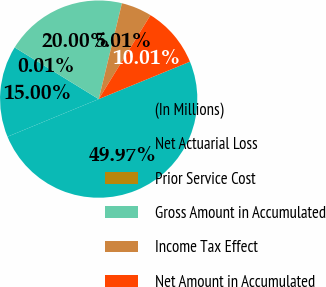Convert chart. <chart><loc_0><loc_0><loc_500><loc_500><pie_chart><fcel>(In Millions)<fcel>Net Actuarial Loss<fcel>Prior Service Cost<fcel>Gross Amount in Accumulated<fcel>Income Tax Effect<fcel>Net Amount in Accumulated<nl><fcel>49.97%<fcel>15.0%<fcel>0.01%<fcel>20.0%<fcel>5.01%<fcel>10.01%<nl></chart> 